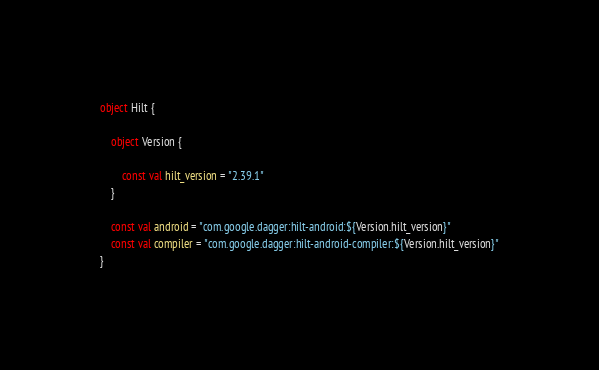Convert code to text. <code><loc_0><loc_0><loc_500><loc_500><_Kotlin_>object Hilt {

    object Version {

        const val hilt_version = "2.39.1"
    }

    const val android = "com.google.dagger:hilt-android:${Version.hilt_version}"
    const val compiler = "com.google.dagger:hilt-android-compiler:${Version.hilt_version}"
}</code> 